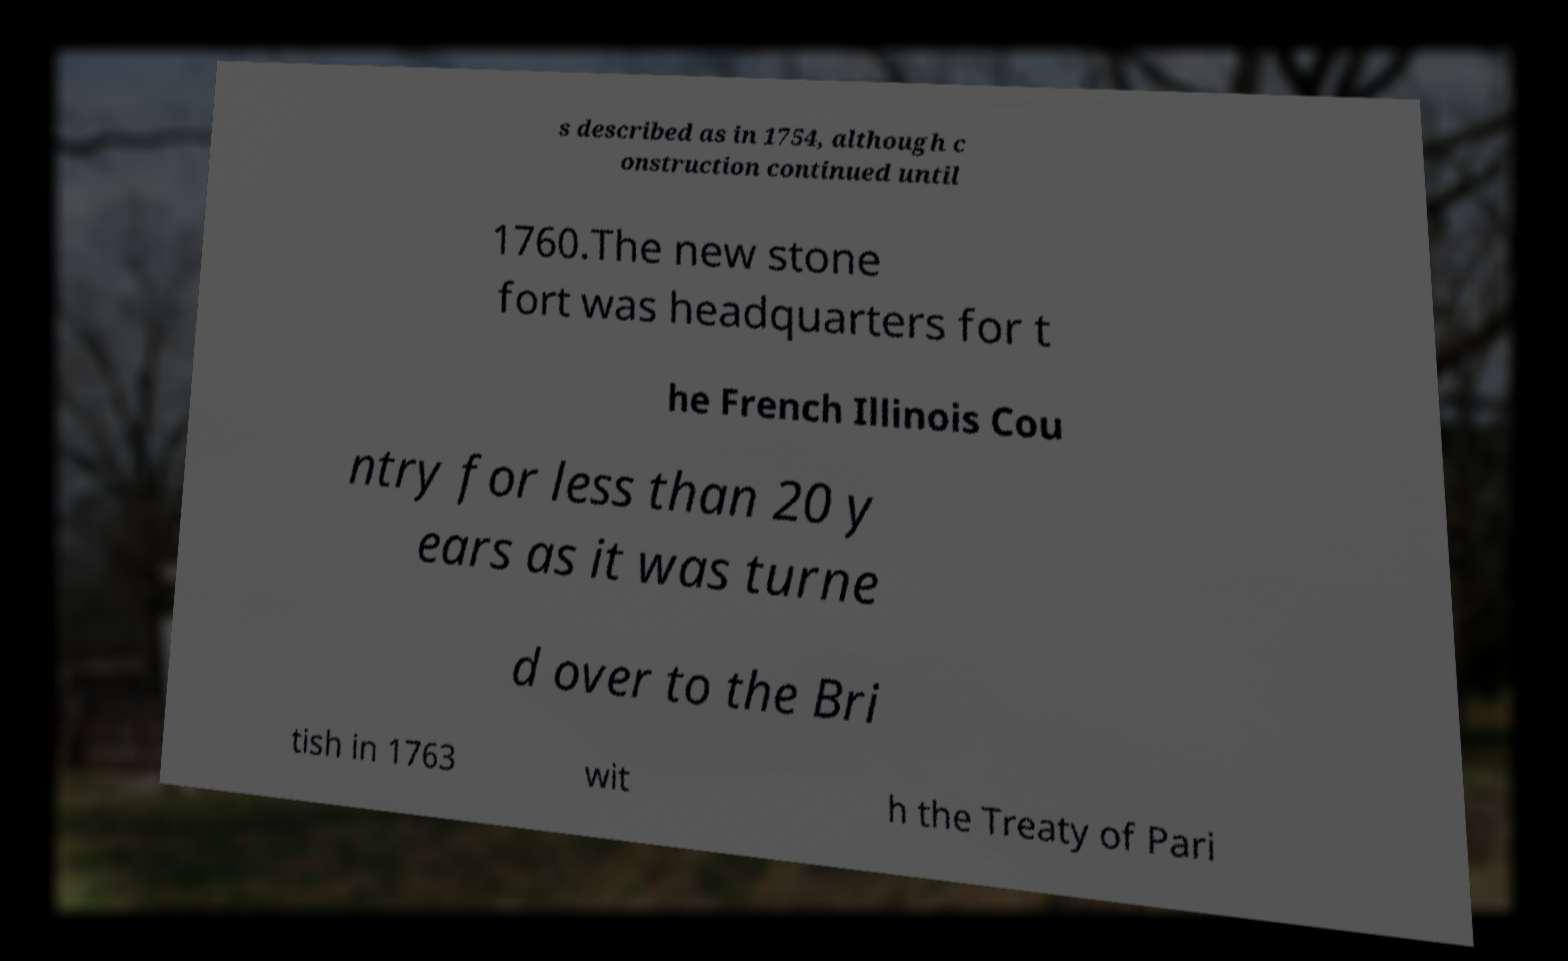Can you accurately transcribe the text from the provided image for me? s described as in 1754, although c onstruction continued until 1760.The new stone fort was headquarters for t he French Illinois Cou ntry for less than 20 y ears as it was turne d over to the Bri tish in 1763 wit h the Treaty of Pari 